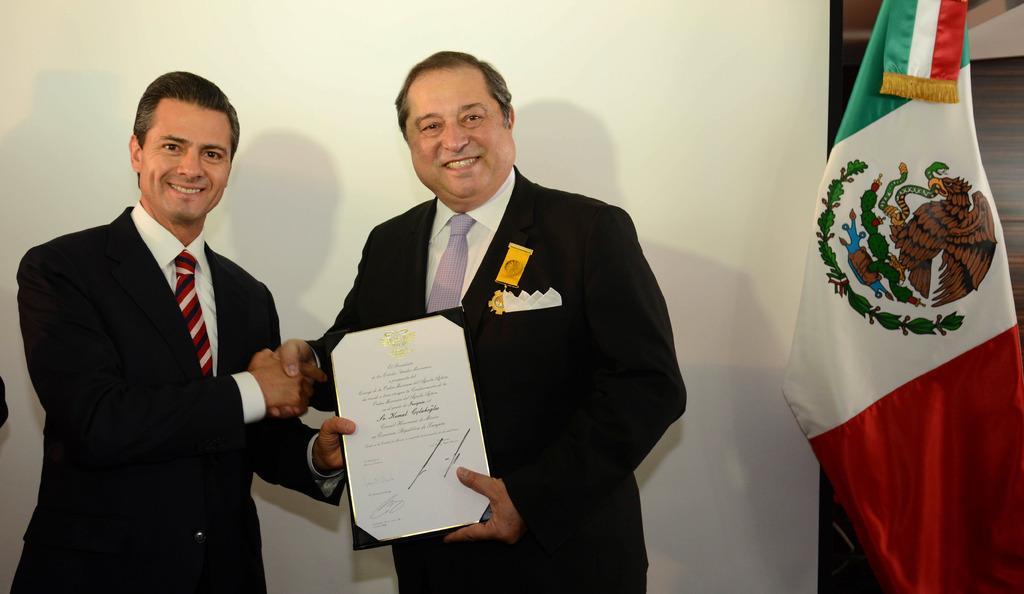How many people are in the image? There are two persons in the image. What are the two persons doing in the image? The two persons are shaking hands and holding a certificate. What can be seen in the background of the image? There is a wall in the background of the image. What is located on the right side of the image? There is a flag on the right side of the image. What type of wire is being used by the minister in the image? There is no minister present in the image, and no wire is visible. What time does the watch in the image show? There is no watch present in the image. 